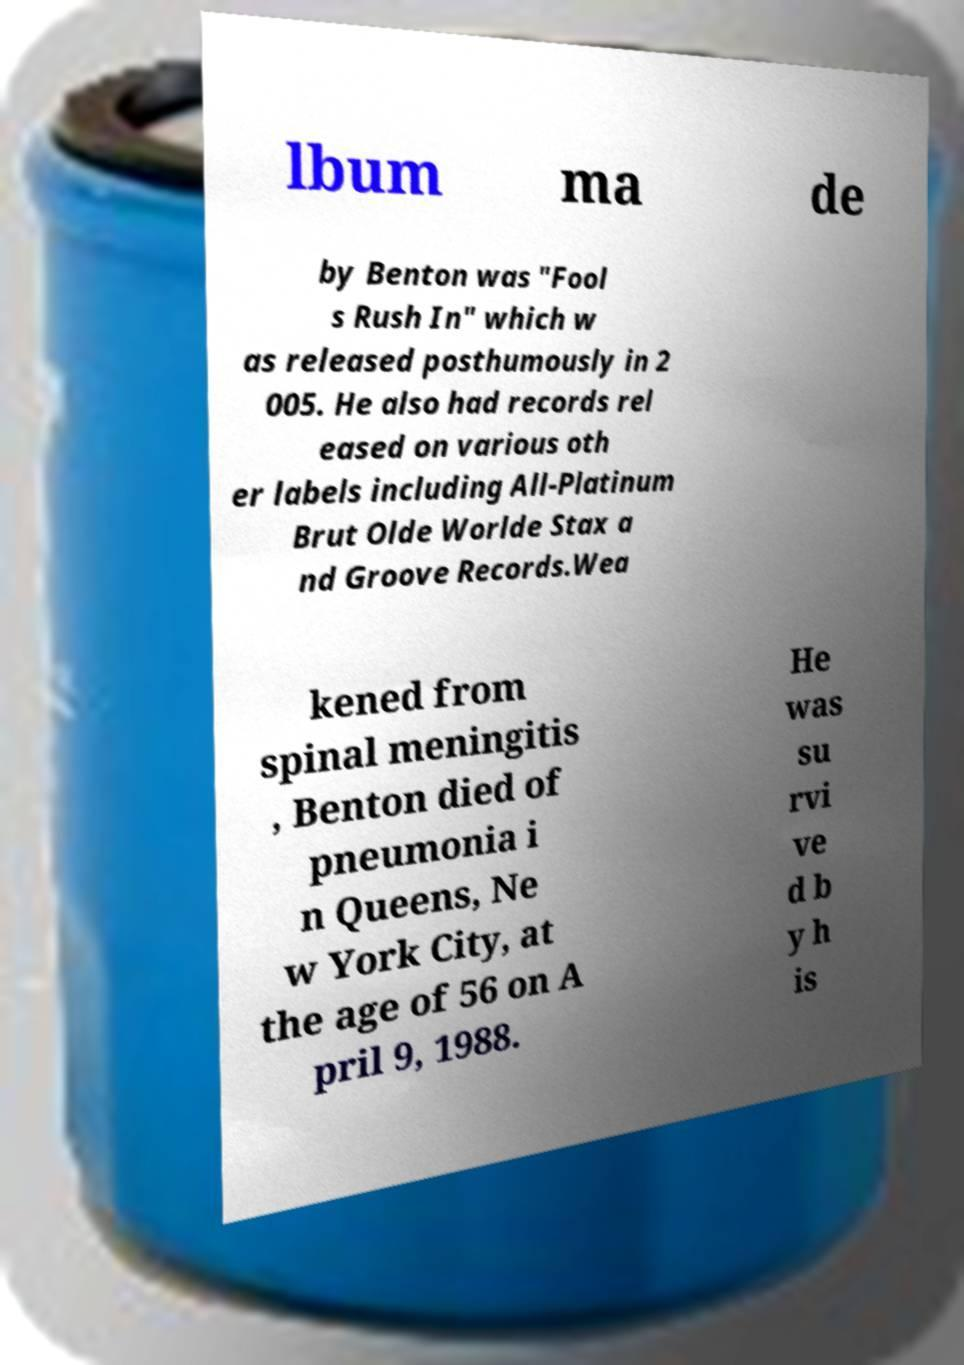Can you accurately transcribe the text from the provided image for me? lbum ma de by Benton was "Fool s Rush In" which w as released posthumously in 2 005. He also had records rel eased on various oth er labels including All-Platinum Brut Olde Worlde Stax a nd Groove Records.Wea kened from spinal meningitis , Benton died of pneumonia i n Queens, Ne w York City, at the age of 56 on A pril 9, 1988. He was su rvi ve d b y h is 